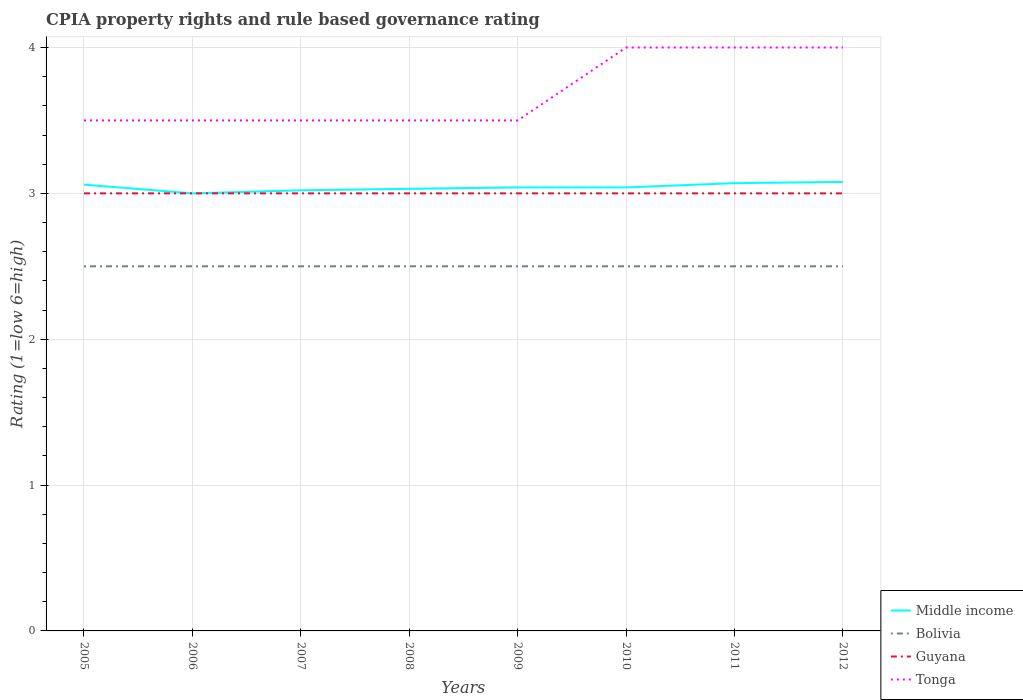Does the line corresponding to Guyana intersect with the line corresponding to Middle income?
Give a very brief answer. Yes. Across all years, what is the maximum CPIA rating in Guyana?
Your response must be concise. 3. What is the total CPIA rating in Bolivia in the graph?
Keep it short and to the point. 0. What is the difference between the highest and the second highest CPIA rating in Tonga?
Ensure brevity in your answer.  0.5. What is the difference between the highest and the lowest CPIA rating in Guyana?
Provide a short and direct response. 0. Is the CPIA rating in Tonga strictly greater than the CPIA rating in Bolivia over the years?
Offer a very short reply. No. How many years are there in the graph?
Provide a succinct answer. 8. Does the graph contain any zero values?
Offer a very short reply. No. Does the graph contain grids?
Your response must be concise. Yes. Where does the legend appear in the graph?
Provide a succinct answer. Bottom right. How many legend labels are there?
Keep it short and to the point. 4. What is the title of the graph?
Offer a terse response. CPIA property rights and rule based governance rating. Does "Mauritania" appear as one of the legend labels in the graph?
Keep it short and to the point. No. What is the Rating (1=low 6=high) in Middle income in 2005?
Your response must be concise. 3.06. What is the Rating (1=low 6=high) in Middle income in 2006?
Offer a terse response. 3. What is the Rating (1=low 6=high) of Bolivia in 2006?
Ensure brevity in your answer.  2.5. What is the Rating (1=low 6=high) of Tonga in 2006?
Keep it short and to the point. 3.5. What is the Rating (1=low 6=high) of Middle income in 2007?
Offer a very short reply. 3.02. What is the Rating (1=low 6=high) in Middle income in 2008?
Offer a terse response. 3.03. What is the Rating (1=low 6=high) in Bolivia in 2008?
Provide a short and direct response. 2.5. What is the Rating (1=low 6=high) in Guyana in 2008?
Your answer should be very brief. 3. What is the Rating (1=low 6=high) of Middle income in 2009?
Provide a succinct answer. 3.04. What is the Rating (1=low 6=high) of Guyana in 2009?
Ensure brevity in your answer.  3. What is the Rating (1=low 6=high) of Tonga in 2009?
Ensure brevity in your answer.  3.5. What is the Rating (1=low 6=high) in Middle income in 2010?
Provide a short and direct response. 3.04. What is the Rating (1=low 6=high) of Guyana in 2010?
Offer a very short reply. 3. What is the Rating (1=low 6=high) of Tonga in 2010?
Your response must be concise. 4. What is the Rating (1=low 6=high) in Middle income in 2011?
Provide a succinct answer. 3.07. What is the Rating (1=low 6=high) in Guyana in 2011?
Provide a succinct answer. 3. What is the Rating (1=low 6=high) in Tonga in 2011?
Offer a terse response. 4. What is the Rating (1=low 6=high) of Middle income in 2012?
Your answer should be compact. 3.08. What is the Rating (1=low 6=high) of Bolivia in 2012?
Provide a succinct answer. 2.5. Across all years, what is the maximum Rating (1=low 6=high) of Middle income?
Offer a very short reply. 3.08. Across all years, what is the maximum Rating (1=low 6=high) in Tonga?
Ensure brevity in your answer.  4. Across all years, what is the minimum Rating (1=low 6=high) in Middle income?
Your answer should be compact. 3. What is the total Rating (1=low 6=high) in Middle income in the graph?
Provide a short and direct response. 24.34. What is the total Rating (1=low 6=high) in Guyana in the graph?
Provide a succinct answer. 24. What is the total Rating (1=low 6=high) of Tonga in the graph?
Make the answer very short. 29.5. What is the difference between the Rating (1=low 6=high) in Middle income in 2005 and that in 2006?
Provide a short and direct response. 0.06. What is the difference between the Rating (1=low 6=high) in Bolivia in 2005 and that in 2006?
Keep it short and to the point. 0. What is the difference between the Rating (1=low 6=high) of Middle income in 2005 and that in 2007?
Your response must be concise. 0.04. What is the difference between the Rating (1=low 6=high) in Guyana in 2005 and that in 2007?
Your answer should be very brief. 0. What is the difference between the Rating (1=low 6=high) in Tonga in 2005 and that in 2007?
Provide a short and direct response. 0. What is the difference between the Rating (1=low 6=high) of Middle income in 2005 and that in 2008?
Ensure brevity in your answer.  0.03. What is the difference between the Rating (1=low 6=high) in Bolivia in 2005 and that in 2008?
Keep it short and to the point. 0. What is the difference between the Rating (1=low 6=high) in Guyana in 2005 and that in 2008?
Your answer should be very brief. 0. What is the difference between the Rating (1=low 6=high) in Middle income in 2005 and that in 2009?
Offer a terse response. 0.02. What is the difference between the Rating (1=low 6=high) of Guyana in 2005 and that in 2009?
Make the answer very short. 0. What is the difference between the Rating (1=low 6=high) of Tonga in 2005 and that in 2009?
Give a very brief answer. 0. What is the difference between the Rating (1=low 6=high) of Middle income in 2005 and that in 2010?
Keep it short and to the point. 0.02. What is the difference between the Rating (1=low 6=high) in Bolivia in 2005 and that in 2010?
Ensure brevity in your answer.  0. What is the difference between the Rating (1=low 6=high) in Guyana in 2005 and that in 2010?
Offer a terse response. 0. What is the difference between the Rating (1=low 6=high) in Middle income in 2005 and that in 2011?
Your answer should be compact. -0.01. What is the difference between the Rating (1=low 6=high) in Guyana in 2005 and that in 2011?
Provide a short and direct response. 0. What is the difference between the Rating (1=low 6=high) of Tonga in 2005 and that in 2011?
Keep it short and to the point. -0.5. What is the difference between the Rating (1=low 6=high) in Middle income in 2005 and that in 2012?
Offer a terse response. -0.02. What is the difference between the Rating (1=low 6=high) in Bolivia in 2005 and that in 2012?
Provide a short and direct response. 0. What is the difference between the Rating (1=low 6=high) of Middle income in 2006 and that in 2007?
Your response must be concise. -0.02. What is the difference between the Rating (1=low 6=high) of Bolivia in 2006 and that in 2007?
Provide a short and direct response. 0. What is the difference between the Rating (1=low 6=high) of Tonga in 2006 and that in 2007?
Make the answer very short. 0. What is the difference between the Rating (1=low 6=high) of Middle income in 2006 and that in 2008?
Provide a succinct answer. -0.03. What is the difference between the Rating (1=low 6=high) of Bolivia in 2006 and that in 2008?
Make the answer very short. 0. What is the difference between the Rating (1=low 6=high) of Guyana in 2006 and that in 2008?
Ensure brevity in your answer.  0. What is the difference between the Rating (1=low 6=high) of Tonga in 2006 and that in 2008?
Provide a succinct answer. 0. What is the difference between the Rating (1=low 6=high) in Middle income in 2006 and that in 2009?
Your answer should be compact. -0.04. What is the difference between the Rating (1=low 6=high) in Middle income in 2006 and that in 2010?
Offer a very short reply. -0.04. What is the difference between the Rating (1=low 6=high) in Guyana in 2006 and that in 2010?
Provide a short and direct response. 0. What is the difference between the Rating (1=low 6=high) of Tonga in 2006 and that in 2010?
Provide a succinct answer. -0.5. What is the difference between the Rating (1=low 6=high) of Middle income in 2006 and that in 2011?
Make the answer very short. -0.07. What is the difference between the Rating (1=low 6=high) in Bolivia in 2006 and that in 2011?
Provide a succinct answer. 0. What is the difference between the Rating (1=low 6=high) of Middle income in 2006 and that in 2012?
Your answer should be very brief. -0.08. What is the difference between the Rating (1=low 6=high) of Bolivia in 2006 and that in 2012?
Provide a short and direct response. 0. What is the difference between the Rating (1=low 6=high) in Guyana in 2006 and that in 2012?
Offer a very short reply. 0. What is the difference between the Rating (1=low 6=high) of Tonga in 2006 and that in 2012?
Keep it short and to the point. -0.5. What is the difference between the Rating (1=low 6=high) in Middle income in 2007 and that in 2008?
Your answer should be very brief. -0.01. What is the difference between the Rating (1=low 6=high) of Tonga in 2007 and that in 2008?
Provide a succinct answer. 0. What is the difference between the Rating (1=low 6=high) in Middle income in 2007 and that in 2009?
Make the answer very short. -0.02. What is the difference between the Rating (1=low 6=high) of Bolivia in 2007 and that in 2009?
Make the answer very short. 0. What is the difference between the Rating (1=low 6=high) in Tonga in 2007 and that in 2009?
Offer a very short reply. 0. What is the difference between the Rating (1=low 6=high) in Middle income in 2007 and that in 2010?
Your answer should be very brief. -0.02. What is the difference between the Rating (1=low 6=high) of Bolivia in 2007 and that in 2010?
Give a very brief answer. 0. What is the difference between the Rating (1=low 6=high) in Tonga in 2007 and that in 2010?
Offer a terse response. -0.5. What is the difference between the Rating (1=low 6=high) of Middle income in 2007 and that in 2011?
Keep it short and to the point. -0.05. What is the difference between the Rating (1=low 6=high) in Bolivia in 2007 and that in 2011?
Make the answer very short. 0. What is the difference between the Rating (1=low 6=high) in Guyana in 2007 and that in 2011?
Make the answer very short. 0. What is the difference between the Rating (1=low 6=high) of Tonga in 2007 and that in 2011?
Your answer should be compact. -0.5. What is the difference between the Rating (1=low 6=high) in Middle income in 2007 and that in 2012?
Your response must be concise. -0.06. What is the difference between the Rating (1=low 6=high) of Bolivia in 2007 and that in 2012?
Your response must be concise. 0. What is the difference between the Rating (1=low 6=high) in Guyana in 2007 and that in 2012?
Make the answer very short. 0. What is the difference between the Rating (1=low 6=high) in Tonga in 2007 and that in 2012?
Your answer should be compact. -0.5. What is the difference between the Rating (1=low 6=high) of Middle income in 2008 and that in 2009?
Provide a succinct answer. -0.01. What is the difference between the Rating (1=low 6=high) of Bolivia in 2008 and that in 2009?
Provide a short and direct response. 0. What is the difference between the Rating (1=low 6=high) in Middle income in 2008 and that in 2010?
Provide a short and direct response. -0.01. What is the difference between the Rating (1=low 6=high) in Bolivia in 2008 and that in 2010?
Ensure brevity in your answer.  0. What is the difference between the Rating (1=low 6=high) in Middle income in 2008 and that in 2011?
Your answer should be very brief. -0.04. What is the difference between the Rating (1=low 6=high) in Guyana in 2008 and that in 2011?
Your response must be concise. 0. What is the difference between the Rating (1=low 6=high) of Middle income in 2008 and that in 2012?
Your response must be concise. -0.05. What is the difference between the Rating (1=low 6=high) in Guyana in 2008 and that in 2012?
Your answer should be compact. 0. What is the difference between the Rating (1=low 6=high) of Tonga in 2008 and that in 2012?
Your answer should be very brief. -0.5. What is the difference between the Rating (1=low 6=high) in Guyana in 2009 and that in 2010?
Offer a terse response. 0. What is the difference between the Rating (1=low 6=high) in Middle income in 2009 and that in 2011?
Your answer should be very brief. -0.03. What is the difference between the Rating (1=low 6=high) in Bolivia in 2009 and that in 2011?
Your answer should be compact. 0. What is the difference between the Rating (1=low 6=high) of Guyana in 2009 and that in 2011?
Provide a succinct answer. 0. What is the difference between the Rating (1=low 6=high) in Middle income in 2009 and that in 2012?
Make the answer very short. -0.04. What is the difference between the Rating (1=low 6=high) in Bolivia in 2009 and that in 2012?
Give a very brief answer. 0. What is the difference between the Rating (1=low 6=high) of Tonga in 2009 and that in 2012?
Provide a short and direct response. -0.5. What is the difference between the Rating (1=low 6=high) of Middle income in 2010 and that in 2011?
Offer a very short reply. -0.03. What is the difference between the Rating (1=low 6=high) in Bolivia in 2010 and that in 2011?
Your response must be concise. 0. What is the difference between the Rating (1=low 6=high) of Guyana in 2010 and that in 2011?
Provide a short and direct response. 0. What is the difference between the Rating (1=low 6=high) in Tonga in 2010 and that in 2011?
Provide a succinct answer. 0. What is the difference between the Rating (1=low 6=high) in Middle income in 2010 and that in 2012?
Your answer should be very brief. -0.04. What is the difference between the Rating (1=low 6=high) in Guyana in 2010 and that in 2012?
Provide a succinct answer. 0. What is the difference between the Rating (1=low 6=high) of Middle income in 2011 and that in 2012?
Make the answer very short. -0.01. What is the difference between the Rating (1=low 6=high) in Bolivia in 2011 and that in 2012?
Your answer should be compact. 0. What is the difference between the Rating (1=low 6=high) of Guyana in 2011 and that in 2012?
Offer a very short reply. 0. What is the difference between the Rating (1=low 6=high) in Middle income in 2005 and the Rating (1=low 6=high) in Bolivia in 2006?
Your answer should be very brief. 0.56. What is the difference between the Rating (1=low 6=high) in Middle income in 2005 and the Rating (1=low 6=high) in Tonga in 2006?
Your response must be concise. -0.44. What is the difference between the Rating (1=low 6=high) in Bolivia in 2005 and the Rating (1=low 6=high) in Guyana in 2006?
Offer a very short reply. -0.5. What is the difference between the Rating (1=low 6=high) of Guyana in 2005 and the Rating (1=low 6=high) of Tonga in 2006?
Make the answer very short. -0.5. What is the difference between the Rating (1=low 6=high) in Middle income in 2005 and the Rating (1=low 6=high) in Bolivia in 2007?
Your response must be concise. 0.56. What is the difference between the Rating (1=low 6=high) of Middle income in 2005 and the Rating (1=low 6=high) of Guyana in 2007?
Your answer should be very brief. 0.06. What is the difference between the Rating (1=low 6=high) of Middle income in 2005 and the Rating (1=low 6=high) of Tonga in 2007?
Offer a very short reply. -0.44. What is the difference between the Rating (1=low 6=high) of Bolivia in 2005 and the Rating (1=low 6=high) of Tonga in 2007?
Your answer should be very brief. -1. What is the difference between the Rating (1=low 6=high) in Middle income in 2005 and the Rating (1=low 6=high) in Bolivia in 2008?
Your answer should be very brief. 0.56. What is the difference between the Rating (1=low 6=high) of Middle income in 2005 and the Rating (1=low 6=high) of Tonga in 2008?
Your answer should be very brief. -0.44. What is the difference between the Rating (1=low 6=high) in Middle income in 2005 and the Rating (1=low 6=high) in Bolivia in 2009?
Provide a short and direct response. 0.56. What is the difference between the Rating (1=low 6=high) in Middle income in 2005 and the Rating (1=low 6=high) in Guyana in 2009?
Make the answer very short. 0.06. What is the difference between the Rating (1=low 6=high) of Middle income in 2005 and the Rating (1=low 6=high) of Tonga in 2009?
Make the answer very short. -0.44. What is the difference between the Rating (1=low 6=high) of Guyana in 2005 and the Rating (1=low 6=high) of Tonga in 2009?
Your answer should be very brief. -0.5. What is the difference between the Rating (1=low 6=high) of Middle income in 2005 and the Rating (1=low 6=high) of Bolivia in 2010?
Make the answer very short. 0.56. What is the difference between the Rating (1=low 6=high) in Middle income in 2005 and the Rating (1=low 6=high) in Tonga in 2010?
Offer a very short reply. -0.94. What is the difference between the Rating (1=low 6=high) of Bolivia in 2005 and the Rating (1=low 6=high) of Tonga in 2010?
Your answer should be very brief. -1.5. What is the difference between the Rating (1=low 6=high) in Middle income in 2005 and the Rating (1=low 6=high) in Bolivia in 2011?
Give a very brief answer. 0.56. What is the difference between the Rating (1=low 6=high) of Middle income in 2005 and the Rating (1=low 6=high) of Guyana in 2011?
Your answer should be compact. 0.06. What is the difference between the Rating (1=low 6=high) in Middle income in 2005 and the Rating (1=low 6=high) in Tonga in 2011?
Offer a very short reply. -0.94. What is the difference between the Rating (1=low 6=high) in Middle income in 2005 and the Rating (1=low 6=high) in Bolivia in 2012?
Provide a short and direct response. 0.56. What is the difference between the Rating (1=low 6=high) in Middle income in 2005 and the Rating (1=low 6=high) in Tonga in 2012?
Give a very brief answer. -0.94. What is the difference between the Rating (1=low 6=high) of Bolivia in 2005 and the Rating (1=low 6=high) of Guyana in 2012?
Offer a terse response. -0.5. What is the difference between the Rating (1=low 6=high) of Bolivia in 2005 and the Rating (1=low 6=high) of Tonga in 2012?
Your answer should be compact. -1.5. What is the difference between the Rating (1=low 6=high) in Middle income in 2006 and the Rating (1=low 6=high) in Bolivia in 2007?
Give a very brief answer. 0.5. What is the difference between the Rating (1=low 6=high) of Middle income in 2006 and the Rating (1=low 6=high) of Guyana in 2007?
Your response must be concise. 0. What is the difference between the Rating (1=low 6=high) of Middle income in 2006 and the Rating (1=low 6=high) of Tonga in 2007?
Provide a succinct answer. -0.5. What is the difference between the Rating (1=low 6=high) in Bolivia in 2006 and the Rating (1=low 6=high) in Guyana in 2007?
Your response must be concise. -0.5. What is the difference between the Rating (1=low 6=high) of Bolivia in 2006 and the Rating (1=low 6=high) of Tonga in 2007?
Offer a very short reply. -1. What is the difference between the Rating (1=low 6=high) of Guyana in 2006 and the Rating (1=low 6=high) of Tonga in 2007?
Provide a short and direct response. -0.5. What is the difference between the Rating (1=low 6=high) in Bolivia in 2006 and the Rating (1=low 6=high) in Guyana in 2008?
Offer a very short reply. -0.5. What is the difference between the Rating (1=low 6=high) of Guyana in 2006 and the Rating (1=low 6=high) of Tonga in 2008?
Provide a short and direct response. -0.5. What is the difference between the Rating (1=low 6=high) in Middle income in 2006 and the Rating (1=low 6=high) in Guyana in 2009?
Provide a short and direct response. 0. What is the difference between the Rating (1=low 6=high) of Middle income in 2006 and the Rating (1=low 6=high) of Tonga in 2009?
Offer a terse response. -0.5. What is the difference between the Rating (1=low 6=high) in Bolivia in 2006 and the Rating (1=low 6=high) in Guyana in 2009?
Your response must be concise. -0.5. What is the difference between the Rating (1=low 6=high) of Bolivia in 2006 and the Rating (1=low 6=high) of Tonga in 2009?
Make the answer very short. -1. What is the difference between the Rating (1=low 6=high) of Guyana in 2006 and the Rating (1=low 6=high) of Tonga in 2009?
Make the answer very short. -0.5. What is the difference between the Rating (1=low 6=high) of Middle income in 2006 and the Rating (1=low 6=high) of Guyana in 2010?
Your answer should be compact. 0. What is the difference between the Rating (1=low 6=high) of Bolivia in 2006 and the Rating (1=low 6=high) of Tonga in 2010?
Your answer should be compact. -1.5. What is the difference between the Rating (1=low 6=high) of Middle income in 2006 and the Rating (1=low 6=high) of Bolivia in 2011?
Your answer should be compact. 0.5. What is the difference between the Rating (1=low 6=high) of Middle income in 2006 and the Rating (1=low 6=high) of Guyana in 2011?
Make the answer very short. 0. What is the difference between the Rating (1=low 6=high) of Middle income in 2006 and the Rating (1=low 6=high) of Tonga in 2011?
Ensure brevity in your answer.  -1. What is the difference between the Rating (1=low 6=high) of Guyana in 2006 and the Rating (1=low 6=high) of Tonga in 2011?
Make the answer very short. -1. What is the difference between the Rating (1=low 6=high) of Middle income in 2006 and the Rating (1=low 6=high) of Guyana in 2012?
Your answer should be very brief. 0. What is the difference between the Rating (1=low 6=high) of Middle income in 2006 and the Rating (1=low 6=high) of Tonga in 2012?
Your answer should be very brief. -1. What is the difference between the Rating (1=low 6=high) in Bolivia in 2006 and the Rating (1=low 6=high) in Guyana in 2012?
Provide a succinct answer. -0.5. What is the difference between the Rating (1=low 6=high) in Bolivia in 2006 and the Rating (1=low 6=high) in Tonga in 2012?
Give a very brief answer. -1.5. What is the difference between the Rating (1=low 6=high) of Guyana in 2006 and the Rating (1=low 6=high) of Tonga in 2012?
Make the answer very short. -1. What is the difference between the Rating (1=low 6=high) of Middle income in 2007 and the Rating (1=low 6=high) of Bolivia in 2008?
Your response must be concise. 0.52. What is the difference between the Rating (1=low 6=high) in Middle income in 2007 and the Rating (1=low 6=high) in Guyana in 2008?
Offer a terse response. 0.02. What is the difference between the Rating (1=low 6=high) of Middle income in 2007 and the Rating (1=low 6=high) of Tonga in 2008?
Make the answer very short. -0.48. What is the difference between the Rating (1=low 6=high) of Guyana in 2007 and the Rating (1=low 6=high) of Tonga in 2008?
Offer a very short reply. -0.5. What is the difference between the Rating (1=low 6=high) of Middle income in 2007 and the Rating (1=low 6=high) of Bolivia in 2009?
Your answer should be compact. 0.52. What is the difference between the Rating (1=low 6=high) of Middle income in 2007 and the Rating (1=low 6=high) of Guyana in 2009?
Provide a succinct answer. 0.02. What is the difference between the Rating (1=low 6=high) of Middle income in 2007 and the Rating (1=low 6=high) of Tonga in 2009?
Your answer should be very brief. -0.48. What is the difference between the Rating (1=low 6=high) of Bolivia in 2007 and the Rating (1=low 6=high) of Guyana in 2009?
Make the answer very short. -0.5. What is the difference between the Rating (1=low 6=high) of Middle income in 2007 and the Rating (1=low 6=high) of Bolivia in 2010?
Keep it short and to the point. 0.52. What is the difference between the Rating (1=low 6=high) in Middle income in 2007 and the Rating (1=low 6=high) in Guyana in 2010?
Offer a very short reply. 0.02. What is the difference between the Rating (1=low 6=high) of Middle income in 2007 and the Rating (1=low 6=high) of Tonga in 2010?
Keep it short and to the point. -0.98. What is the difference between the Rating (1=low 6=high) in Bolivia in 2007 and the Rating (1=low 6=high) in Guyana in 2010?
Give a very brief answer. -0.5. What is the difference between the Rating (1=low 6=high) of Middle income in 2007 and the Rating (1=low 6=high) of Bolivia in 2011?
Provide a succinct answer. 0.52. What is the difference between the Rating (1=low 6=high) of Middle income in 2007 and the Rating (1=low 6=high) of Guyana in 2011?
Your response must be concise. 0.02. What is the difference between the Rating (1=low 6=high) in Middle income in 2007 and the Rating (1=low 6=high) in Tonga in 2011?
Make the answer very short. -0.98. What is the difference between the Rating (1=low 6=high) of Guyana in 2007 and the Rating (1=low 6=high) of Tonga in 2011?
Provide a short and direct response. -1. What is the difference between the Rating (1=low 6=high) of Middle income in 2007 and the Rating (1=low 6=high) of Bolivia in 2012?
Give a very brief answer. 0.52. What is the difference between the Rating (1=low 6=high) of Middle income in 2007 and the Rating (1=low 6=high) of Guyana in 2012?
Keep it short and to the point. 0.02. What is the difference between the Rating (1=low 6=high) in Middle income in 2007 and the Rating (1=low 6=high) in Tonga in 2012?
Offer a terse response. -0.98. What is the difference between the Rating (1=low 6=high) of Bolivia in 2007 and the Rating (1=low 6=high) of Tonga in 2012?
Your answer should be very brief. -1.5. What is the difference between the Rating (1=low 6=high) of Middle income in 2008 and the Rating (1=low 6=high) of Bolivia in 2009?
Your answer should be compact. 0.53. What is the difference between the Rating (1=low 6=high) in Middle income in 2008 and the Rating (1=low 6=high) in Guyana in 2009?
Offer a very short reply. 0.03. What is the difference between the Rating (1=low 6=high) of Middle income in 2008 and the Rating (1=low 6=high) of Tonga in 2009?
Make the answer very short. -0.47. What is the difference between the Rating (1=low 6=high) of Bolivia in 2008 and the Rating (1=low 6=high) of Guyana in 2009?
Offer a terse response. -0.5. What is the difference between the Rating (1=low 6=high) of Guyana in 2008 and the Rating (1=low 6=high) of Tonga in 2009?
Offer a very short reply. -0.5. What is the difference between the Rating (1=low 6=high) in Middle income in 2008 and the Rating (1=low 6=high) in Bolivia in 2010?
Give a very brief answer. 0.53. What is the difference between the Rating (1=low 6=high) in Middle income in 2008 and the Rating (1=low 6=high) in Guyana in 2010?
Make the answer very short. 0.03. What is the difference between the Rating (1=low 6=high) of Middle income in 2008 and the Rating (1=low 6=high) of Tonga in 2010?
Offer a terse response. -0.97. What is the difference between the Rating (1=low 6=high) in Bolivia in 2008 and the Rating (1=low 6=high) in Tonga in 2010?
Offer a very short reply. -1.5. What is the difference between the Rating (1=low 6=high) in Middle income in 2008 and the Rating (1=low 6=high) in Bolivia in 2011?
Your response must be concise. 0.53. What is the difference between the Rating (1=low 6=high) in Middle income in 2008 and the Rating (1=low 6=high) in Guyana in 2011?
Make the answer very short. 0.03. What is the difference between the Rating (1=low 6=high) in Middle income in 2008 and the Rating (1=low 6=high) in Tonga in 2011?
Give a very brief answer. -0.97. What is the difference between the Rating (1=low 6=high) of Bolivia in 2008 and the Rating (1=low 6=high) of Guyana in 2011?
Your answer should be compact. -0.5. What is the difference between the Rating (1=low 6=high) in Bolivia in 2008 and the Rating (1=low 6=high) in Tonga in 2011?
Offer a terse response. -1.5. What is the difference between the Rating (1=low 6=high) of Guyana in 2008 and the Rating (1=low 6=high) of Tonga in 2011?
Ensure brevity in your answer.  -1. What is the difference between the Rating (1=low 6=high) in Middle income in 2008 and the Rating (1=low 6=high) in Bolivia in 2012?
Your answer should be compact. 0.53. What is the difference between the Rating (1=low 6=high) in Middle income in 2008 and the Rating (1=low 6=high) in Guyana in 2012?
Your response must be concise. 0.03. What is the difference between the Rating (1=low 6=high) of Middle income in 2008 and the Rating (1=low 6=high) of Tonga in 2012?
Give a very brief answer. -0.97. What is the difference between the Rating (1=low 6=high) in Bolivia in 2008 and the Rating (1=low 6=high) in Tonga in 2012?
Your answer should be compact. -1.5. What is the difference between the Rating (1=low 6=high) of Middle income in 2009 and the Rating (1=low 6=high) of Bolivia in 2010?
Provide a short and direct response. 0.54. What is the difference between the Rating (1=low 6=high) in Middle income in 2009 and the Rating (1=low 6=high) in Guyana in 2010?
Keep it short and to the point. 0.04. What is the difference between the Rating (1=low 6=high) in Middle income in 2009 and the Rating (1=low 6=high) in Tonga in 2010?
Ensure brevity in your answer.  -0.96. What is the difference between the Rating (1=low 6=high) in Bolivia in 2009 and the Rating (1=low 6=high) in Tonga in 2010?
Your response must be concise. -1.5. What is the difference between the Rating (1=low 6=high) in Guyana in 2009 and the Rating (1=low 6=high) in Tonga in 2010?
Your answer should be compact. -1. What is the difference between the Rating (1=low 6=high) in Middle income in 2009 and the Rating (1=low 6=high) in Bolivia in 2011?
Keep it short and to the point. 0.54. What is the difference between the Rating (1=low 6=high) of Middle income in 2009 and the Rating (1=low 6=high) of Guyana in 2011?
Give a very brief answer. 0.04. What is the difference between the Rating (1=low 6=high) in Middle income in 2009 and the Rating (1=low 6=high) in Tonga in 2011?
Give a very brief answer. -0.96. What is the difference between the Rating (1=low 6=high) of Bolivia in 2009 and the Rating (1=low 6=high) of Guyana in 2011?
Offer a terse response. -0.5. What is the difference between the Rating (1=low 6=high) in Middle income in 2009 and the Rating (1=low 6=high) in Bolivia in 2012?
Provide a short and direct response. 0.54. What is the difference between the Rating (1=low 6=high) of Middle income in 2009 and the Rating (1=low 6=high) of Guyana in 2012?
Your answer should be compact. 0.04. What is the difference between the Rating (1=low 6=high) in Middle income in 2009 and the Rating (1=low 6=high) in Tonga in 2012?
Give a very brief answer. -0.96. What is the difference between the Rating (1=low 6=high) in Bolivia in 2009 and the Rating (1=low 6=high) in Tonga in 2012?
Your answer should be compact. -1.5. What is the difference between the Rating (1=low 6=high) of Guyana in 2009 and the Rating (1=low 6=high) of Tonga in 2012?
Provide a short and direct response. -1. What is the difference between the Rating (1=low 6=high) in Middle income in 2010 and the Rating (1=low 6=high) in Bolivia in 2011?
Make the answer very short. 0.54. What is the difference between the Rating (1=low 6=high) of Middle income in 2010 and the Rating (1=low 6=high) of Guyana in 2011?
Make the answer very short. 0.04. What is the difference between the Rating (1=low 6=high) in Middle income in 2010 and the Rating (1=low 6=high) in Tonga in 2011?
Ensure brevity in your answer.  -0.96. What is the difference between the Rating (1=low 6=high) of Bolivia in 2010 and the Rating (1=low 6=high) of Guyana in 2011?
Your answer should be compact. -0.5. What is the difference between the Rating (1=low 6=high) in Guyana in 2010 and the Rating (1=low 6=high) in Tonga in 2011?
Offer a very short reply. -1. What is the difference between the Rating (1=low 6=high) of Middle income in 2010 and the Rating (1=low 6=high) of Bolivia in 2012?
Your answer should be very brief. 0.54. What is the difference between the Rating (1=low 6=high) of Middle income in 2010 and the Rating (1=low 6=high) of Guyana in 2012?
Provide a short and direct response. 0.04. What is the difference between the Rating (1=low 6=high) in Middle income in 2010 and the Rating (1=low 6=high) in Tonga in 2012?
Ensure brevity in your answer.  -0.96. What is the difference between the Rating (1=low 6=high) in Bolivia in 2010 and the Rating (1=low 6=high) in Guyana in 2012?
Ensure brevity in your answer.  -0.5. What is the difference between the Rating (1=low 6=high) of Guyana in 2010 and the Rating (1=low 6=high) of Tonga in 2012?
Your answer should be compact. -1. What is the difference between the Rating (1=low 6=high) of Middle income in 2011 and the Rating (1=low 6=high) of Bolivia in 2012?
Your response must be concise. 0.57. What is the difference between the Rating (1=low 6=high) of Middle income in 2011 and the Rating (1=low 6=high) of Guyana in 2012?
Make the answer very short. 0.07. What is the difference between the Rating (1=low 6=high) in Middle income in 2011 and the Rating (1=low 6=high) in Tonga in 2012?
Give a very brief answer. -0.93. What is the difference between the Rating (1=low 6=high) in Bolivia in 2011 and the Rating (1=low 6=high) in Tonga in 2012?
Your answer should be very brief. -1.5. What is the average Rating (1=low 6=high) in Middle income per year?
Give a very brief answer. 3.04. What is the average Rating (1=low 6=high) of Guyana per year?
Give a very brief answer. 3. What is the average Rating (1=low 6=high) of Tonga per year?
Provide a succinct answer. 3.69. In the year 2005, what is the difference between the Rating (1=low 6=high) of Middle income and Rating (1=low 6=high) of Bolivia?
Make the answer very short. 0.56. In the year 2005, what is the difference between the Rating (1=low 6=high) in Middle income and Rating (1=low 6=high) in Tonga?
Your response must be concise. -0.44. In the year 2005, what is the difference between the Rating (1=low 6=high) in Bolivia and Rating (1=low 6=high) in Tonga?
Offer a very short reply. -1. In the year 2006, what is the difference between the Rating (1=low 6=high) of Middle income and Rating (1=low 6=high) of Guyana?
Provide a short and direct response. 0. In the year 2006, what is the difference between the Rating (1=low 6=high) of Middle income and Rating (1=low 6=high) of Tonga?
Provide a short and direct response. -0.5. In the year 2006, what is the difference between the Rating (1=low 6=high) in Bolivia and Rating (1=low 6=high) in Guyana?
Your answer should be compact. -0.5. In the year 2006, what is the difference between the Rating (1=low 6=high) in Bolivia and Rating (1=low 6=high) in Tonga?
Make the answer very short. -1. In the year 2006, what is the difference between the Rating (1=low 6=high) in Guyana and Rating (1=low 6=high) in Tonga?
Ensure brevity in your answer.  -0.5. In the year 2007, what is the difference between the Rating (1=low 6=high) of Middle income and Rating (1=low 6=high) of Bolivia?
Make the answer very short. 0.52. In the year 2007, what is the difference between the Rating (1=low 6=high) of Middle income and Rating (1=low 6=high) of Guyana?
Provide a short and direct response. 0.02. In the year 2007, what is the difference between the Rating (1=low 6=high) of Middle income and Rating (1=low 6=high) of Tonga?
Give a very brief answer. -0.48. In the year 2007, what is the difference between the Rating (1=low 6=high) of Bolivia and Rating (1=low 6=high) of Guyana?
Offer a terse response. -0.5. In the year 2008, what is the difference between the Rating (1=low 6=high) in Middle income and Rating (1=low 6=high) in Bolivia?
Provide a succinct answer. 0.53. In the year 2008, what is the difference between the Rating (1=low 6=high) in Middle income and Rating (1=low 6=high) in Guyana?
Make the answer very short. 0.03. In the year 2008, what is the difference between the Rating (1=low 6=high) in Middle income and Rating (1=low 6=high) in Tonga?
Your answer should be very brief. -0.47. In the year 2008, what is the difference between the Rating (1=low 6=high) of Bolivia and Rating (1=low 6=high) of Guyana?
Provide a short and direct response. -0.5. In the year 2008, what is the difference between the Rating (1=low 6=high) in Guyana and Rating (1=low 6=high) in Tonga?
Your answer should be compact. -0.5. In the year 2009, what is the difference between the Rating (1=low 6=high) in Middle income and Rating (1=low 6=high) in Bolivia?
Keep it short and to the point. 0.54. In the year 2009, what is the difference between the Rating (1=low 6=high) of Middle income and Rating (1=low 6=high) of Guyana?
Offer a very short reply. 0.04. In the year 2009, what is the difference between the Rating (1=low 6=high) in Middle income and Rating (1=low 6=high) in Tonga?
Keep it short and to the point. -0.46. In the year 2009, what is the difference between the Rating (1=low 6=high) in Guyana and Rating (1=low 6=high) in Tonga?
Your answer should be very brief. -0.5. In the year 2010, what is the difference between the Rating (1=low 6=high) of Middle income and Rating (1=low 6=high) of Bolivia?
Make the answer very short. 0.54. In the year 2010, what is the difference between the Rating (1=low 6=high) in Middle income and Rating (1=low 6=high) in Guyana?
Provide a succinct answer. 0.04. In the year 2010, what is the difference between the Rating (1=low 6=high) of Middle income and Rating (1=low 6=high) of Tonga?
Your answer should be very brief. -0.96. In the year 2010, what is the difference between the Rating (1=low 6=high) of Bolivia and Rating (1=low 6=high) of Guyana?
Offer a terse response. -0.5. In the year 2010, what is the difference between the Rating (1=low 6=high) of Guyana and Rating (1=low 6=high) of Tonga?
Your answer should be very brief. -1. In the year 2011, what is the difference between the Rating (1=low 6=high) in Middle income and Rating (1=low 6=high) in Bolivia?
Provide a short and direct response. 0.57. In the year 2011, what is the difference between the Rating (1=low 6=high) of Middle income and Rating (1=low 6=high) of Guyana?
Your answer should be very brief. 0.07. In the year 2011, what is the difference between the Rating (1=low 6=high) in Middle income and Rating (1=low 6=high) in Tonga?
Your response must be concise. -0.93. In the year 2011, what is the difference between the Rating (1=low 6=high) of Guyana and Rating (1=low 6=high) of Tonga?
Your response must be concise. -1. In the year 2012, what is the difference between the Rating (1=low 6=high) in Middle income and Rating (1=low 6=high) in Bolivia?
Make the answer very short. 0.58. In the year 2012, what is the difference between the Rating (1=low 6=high) in Middle income and Rating (1=low 6=high) in Guyana?
Ensure brevity in your answer.  0.08. In the year 2012, what is the difference between the Rating (1=low 6=high) of Middle income and Rating (1=low 6=high) of Tonga?
Provide a succinct answer. -0.92. In the year 2012, what is the difference between the Rating (1=low 6=high) in Bolivia and Rating (1=low 6=high) in Guyana?
Give a very brief answer. -0.5. In the year 2012, what is the difference between the Rating (1=low 6=high) of Bolivia and Rating (1=low 6=high) of Tonga?
Your answer should be compact. -1.5. In the year 2012, what is the difference between the Rating (1=low 6=high) in Guyana and Rating (1=low 6=high) in Tonga?
Provide a succinct answer. -1. What is the ratio of the Rating (1=low 6=high) of Guyana in 2005 to that in 2006?
Offer a terse response. 1. What is the ratio of the Rating (1=low 6=high) in Tonga in 2005 to that in 2006?
Offer a terse response. 1. What is the ratio of the Rating (1=low 6=high) of Guyana in 2005 to that in 2007?
Ensure brevity in your answer.  1. What is the ratio of the Rating (1=low 6=high) of Tonga in 2005 to that in 2007?
Ensure brevity in your answer.  1. What is the ratio of the Rating (1=low 6=high) of Middle income in 2005 to that in 2008?
Offer a terse response. 1.01. What is the ratio of the Rating (1=low 6=high) of Guyana in 2005 to that in 2008?
Ensure brevity in your answer.  1. What is the ratio of the Rating (1=low 6=high) in Tonga in 2005 to that in 2008?
Your answer should be very brief. 1. What is the ratio of the Rating (1=low 6=high) in Guyana in 2005 to that in 2009?
Give a very brief answer. 1. What is the ratio of the Rating (1=low 6=high) in Bolivia in 2005 to that in 2010?
Provide a short and direct response. 1. What is the ratio of the Rating (1=low 6=high) of Guyana in 2005 to that in 2010?
Make the answer very short. 1. What is the ratio of the Rating (1=low 6=high) of Tonga in 2005 to that in 2010?
Offer a terse response. 0.88. What is the ratio of the Rating (1=low 6=high) of Middle income in 2005 to that in 2011?
Ensure brevity in your answer.  1. What is the ratio of the Rating (1=low 6=high) of Tonga in 2005 to that in 2011?
Make the answer very short. 0.88. What is the ratio of the Rating (1=low 6=high) of Middle income in 2005 to that in 2012?
Your response must be concise. 0.99. What is the ratio of the Rating (1=low 6=high) in Guyana in 2005 to that in 2012?
Your response must be concise. 1. What is the ratio of the Rating (1=low 6=high) in Bolivia in 2006 to that in 2007?
Your response must be concise. 1. What is the ratio of the Rating (1=low 6=high) in Guyana in 2006 to that in 2007?
Provide a succinct answer. 1. What is the ratio of the Rating (1=low 6=high) of Middle income in 2006 to that in 2008?
Ensure brevity in your answer.  0.99. What is the ratio of the Rating (1=low 6=high) of Bolivia in 2006 to that in 2008?
Keep it short and to the point. 1. What is the ratio of the Rating (1=low 6=high) in Tonga in 2006 to that in 2008?
Ensure brevity in your answer.  1. What is the ratio of the Rating (1=low 6=high) in Middle income in 2006 to that in 2009?
Offer a terse response. 0.99. What is the ratio of the Rating (1=low 6=high) of Bolivia in 2006 to that in 2009?
Your response must be concise. 1. What is the ratio of the Rating (1=low 6=high) of Guyana in 2006 to that in 2009?
Your answer should be compact. 1. What is the ratio of the Rating (1=low 6=high) in Tonga in 2006 to that in 2009?
Give a very brief answer. 1. What is the ratio of the Rating (1=low 6=high) in Middle income in 2006 to that in 2010?
Your answer should be very brief. 0.99. What is the ratio of the Rating (1=low 6=high) of Bolivia in 2006 to that in 2010?
Keep it short and to the point. 1. What is the ratio of the Rating (1=low 6=high) in Middle income in 2006 to that in 2011?
Keep it short and to the point. 0.98. What is the ratio of the Rating (1=low 6=high) in Bolivia in 2006 to that in 2011?
Your answer should be compact. 1. What is the ratio of the Rating (1=low 6=high) in Tonga in 2006 to that in 2011?
Offer a very short reply. 0.88. What is the ratio of the Rating (1=low 6=high) of Middle income in 2006 to that in 2012?
Your response must be concise. 0.97. What is the ratio of the Rating (1=low 6=high) in Middle income in 2007 to that in 2009?
Keep it short and to the point. 0.99. What is the ratio of the Rating (1=low 6=high) in Guyana in 2007 to that in 2009?
Your response must be concise. 1. What is the ratio of the Rating (1=low 6=high) of Middle income in 2007 to that in 2010?
Offer a very short reply. 0.99. What is the ratio of the Rating (1=low 6=high) of Bolivia in 2007 to that in 2010?
Your answer should be compact. 1. What is the ratio of the Rating (1=low 6=high) of Tonga in 2007 to that in 2010?
Make the answer very short. 0.88. What is the ratio of the Rating (1=low 6=high) of Guyana in 2007 to that in 2011?
Make the answer very short. 1. What is the ratio of the Rating (1=low 6=high) in Middle income in 2007 to that in 2012?
Your response must be concise. 0.98. What is the ratio of the Rating (1=low 6=high) in Middle income in 2008 to that in 2009?
Make the answer very short. 1. What is the ratio of the Rating (1=low 6=high) in Bolivia in 2008 to that in 2009?
Your response must be concise. 1. What is the ratio of the Rating (1=low 6=high) of Guyana in 2008 to that in 2009?
Keep it short and to the point. 1. What is the ratio of the Rating (1=low 6=high) in Tonga in 2008 to that in 2009?
Ensure brevity in your answer.  1. What is the ratio of the Rating (1=low 6=high) of Tonga in 2008 to that in 2010?
Give a very brief answer. 0.88. What is the ratio of the Rating (1=low 6=high) of Middle income in 2008 to that in 2011?
Provide a short and direct response. 0.99. What is the ratio of the Rating (1=low 6=high) of Guyana in 2008 to that in 2011?
Keep it short and to the point. 1. What is the ratio of the Rating (1=low 6=high) of Tonga in 2008 to that in 2011?
Ensure brevity in your answer.  0.88. What is the ratio of the Rating (1=low 6=high) in Middle income in 2008 to that in 2012?
Offer a terse response. 0.98. What is the ratio of the Rating (1=low 6=high) of Guyana in 2009 to that in 2010?
Provide a succinct answer. 1. What is the ratio of the Rating (1=low 6=high) in Tonga in 2009 to that in 2010?
Give a very brief answer. 0.88. What is the ratio of the Rating (1=low 6=high) of Middle income in 2009 to that in 2011?
Make the answer very short. 0.99. What is the ratio of the Rating (1=low 6=high) in Bolivia in 2009 to that in 2011?
Offer a terse response. 1. What is the ratio of the Rating (1=low 6=high) in Middle income in 2009 to that in 2012?
Your response must be concise. 0.99. What is the ratio of the Rating (1=low 6=high) of Bolivia in 2009 to that in 2012?
Provide a short and direct response. 1. What is the ratio of the Rating (1=low 6=high) of Guyana in 2009 to that in 2012?
Offer a very short reply. 1. What is the ratio of the Rating (1=low 6=high) in Tonga in 2009 to that in 2012?
Your answer should be compact. 0.88. What is the ratio of the Rating (1=low 6=high) of Middle income in 2010 to that in 2011?
Ensure brevity in your answer.  0.99. What is the ratio of the Rating (1=low 6=high) of Tonga in 2010 to that in 2011?
Make the answer very short. 1. What is the ratio of the Rating (1=low 6=high) of Bolivia in 2010 to that in 2012?
Your answer should be very brief. 1. What is the ratio of the Rating (1=low 6=high) of Tonga in 2010 to that in 2012?
Keep it short and to the point. 1. What is the ratio of the Rating (1=low 6=high) in Middle income in 2011 to that in 2012?
Give a very brief answer. 1. What is the ratio of the Rating (1=low 6=high) of Tonga in 2011 to that in 2012?
Ensure brevity in your answer.  1. What is the difference between the highest and the second highest Rating (1=low 6=high) in Middle income?
Make the answer very short. 0.01. What is the difference between the highest and the second highest Rating (1=low 6=high) in Bolivia?
Your answer should be very brief. 0. What is the difference between the highest and the second highest Rating (1=low 6=high) in Guyana?
Offer a terse response. 0. What is the difference between the highest and the lowest Rating (1=low 6=high) in Middle income?
Keep it short and to the point. 0.08. What is the difference between the highest and the lowest Rating (1=low 6=high) in Bolivia?
Offer a terse response. 0. What is the difference between the highest and the lowest Rating (1=low 6=high) in Tonga?
Make the answer very short. 0.5. 